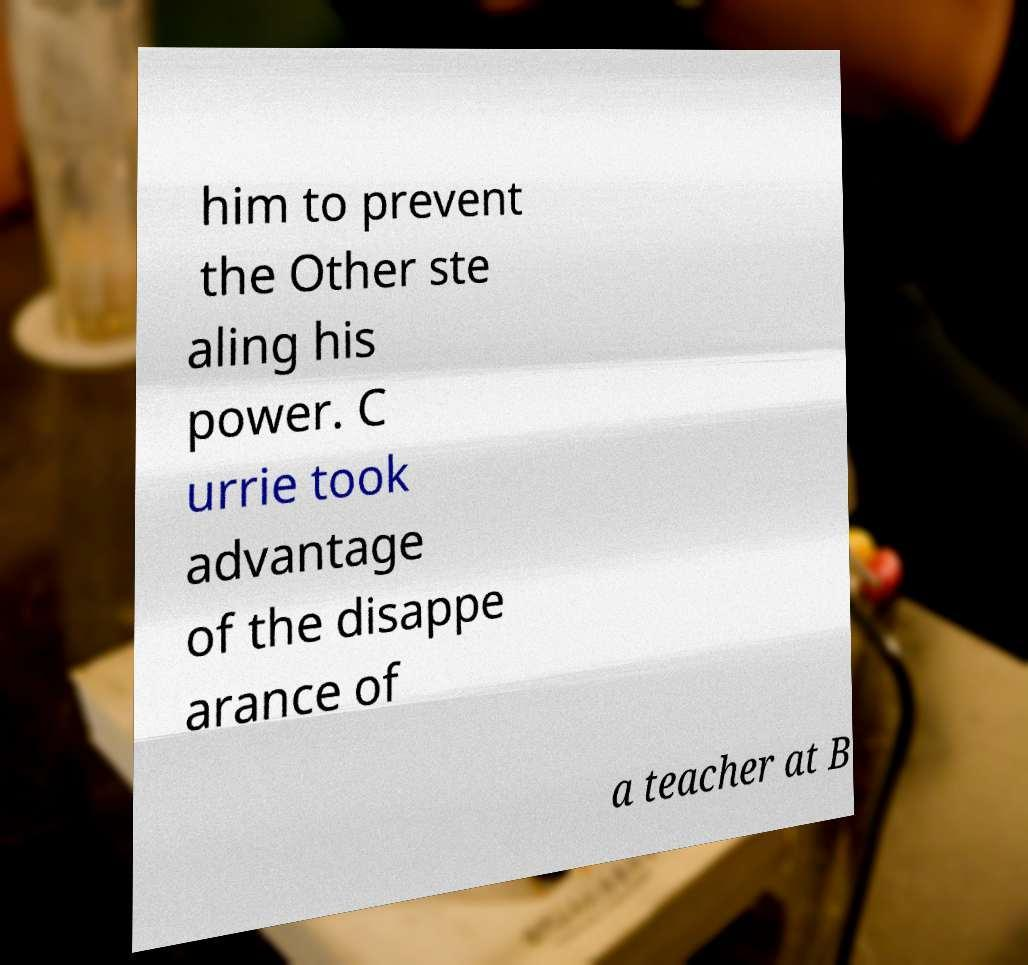For documentation purposes, I need the text within this image transcribed. Could you provide that? him to prevent the Other ste aling his power. C urrie took advantage of the disappe arance of a teacher at B 